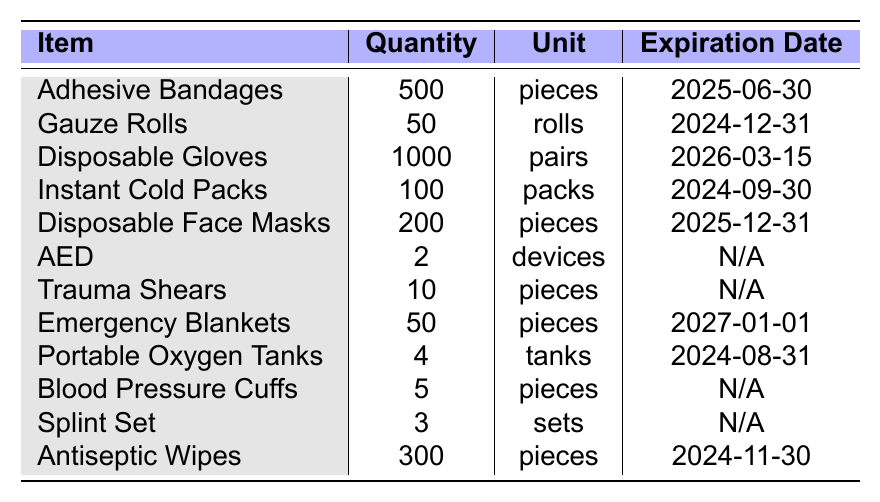What is the total quantity of Adhesive Bandages available? The table lists 500 pieces of Adhesive Bandages under the quantity column.
Answer: 500 How many Disposable Gloves are there in total? The quantity column shows that there are 1000 pairs of Disposable Gloves available.
Answer: 1000 Which item has the earliest expiration date? The expiration dates can be compared, and the earliest one is for Gauze Rolls, expiring on 2024-12-31.
Answer: Gauze Rolls Are there more than 200 Disposable Face Masks? The table shows 200 Disposable Face Masks, which means there are not more than 200.
Answer: No What is the total quantity of all items excluding those that do not have an expiration date? The items without an expiration date are the AED, Trauma Shears, Blood Pressure Cuffs, and Splint Set. Their quantities are 2, 10, 5, and 3 respectively. Summing the others (500 + 50 + 1000 + 100 + 200 + 50 + 4 + 300) gives 2204. Adding the non-expiring items (2 + 10 + 5 + 3) gives a total of 2204 + 20 = 2224.
Answer: 2224 What proportion of the total items are Disposable Gloves? First, determine the total quantity: 500 + 50 + 1000 + 100 + 200 + 2 + 10 + 50 + 4 + 5 + 3 + 300 = 2205. The quantity of Disposable Gloves is 1000. To find the proportion, divide 1000 by 2205, which approximately equals 0.453. So the proportion is 0.453 or 45.3%.
Answer: 0.453 or 45.3% How many items have an expiration date in 2024? The items with expiration dates in 2024 are: Gauze Rolls (2024-12-31), Instant Cold Packs (2024-09-30), Portable Oxygen Tanks (2024-08-31), and Antiseptic Wipes (2024-11-30). There are 4 items in total.
Answer: 4 Is there enough quantity of Emergency Blankets to handle emergencies at a large event? There are 50 Emergency Blankets available. Whether this amount is sufficient depends on the expected number of emergencies and the standard response needed at large events.
Answer: Insufficient information What is the total number of pieces available for items that have an expiration date of 2025 or later? The relevant items are Adhesive Bandages (500), Disposable Face Masks (200), and Emergency Blankets (50). Adding these together gives 500 + 200 + 50 = 750.
Answer: 750 